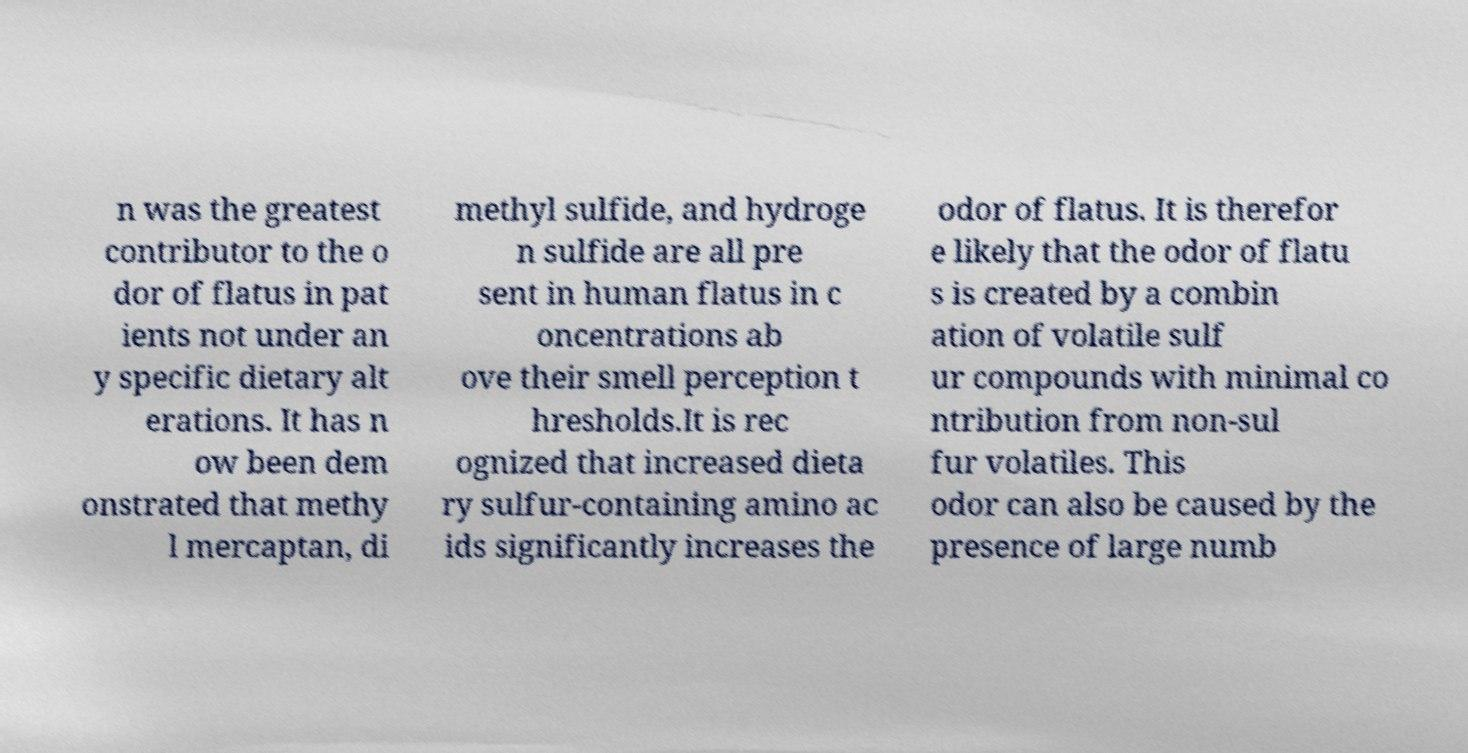For documentation purposes, I need the text within this image transcribed. Could you provide that? n was the greatest contributor to the o dor of flatus in pat ients not under an y specific dietary alt erations. It has n ow been dem onstrated that methy l mercaptan, di methyl sulfide, and hydroge n sulfide are all pre sent in human flatus in c oncentrations ab ove their smell perception t hresholds.It is rec ognized that increased dieta ry sulfur-containing amino ac ids significantly increases the odor of flatus. It is therefor e likely that the odor of flatu s is created by a combin ation of volatile sulf ur compounds with minimal co ntribution from non-sul fur volatiles. This odor can also be caused by the presence of large numb 